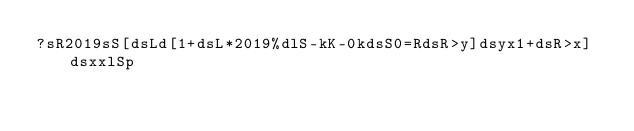<code> <loc_0><loc_0><loc_500><loc_500><_dc_>?sR2019sS[dsLd[1+dsL*2019%dlS-kK-0kdsS0=RdsR>y]dsyx1+dsR>x]dsxxlSp</code> 